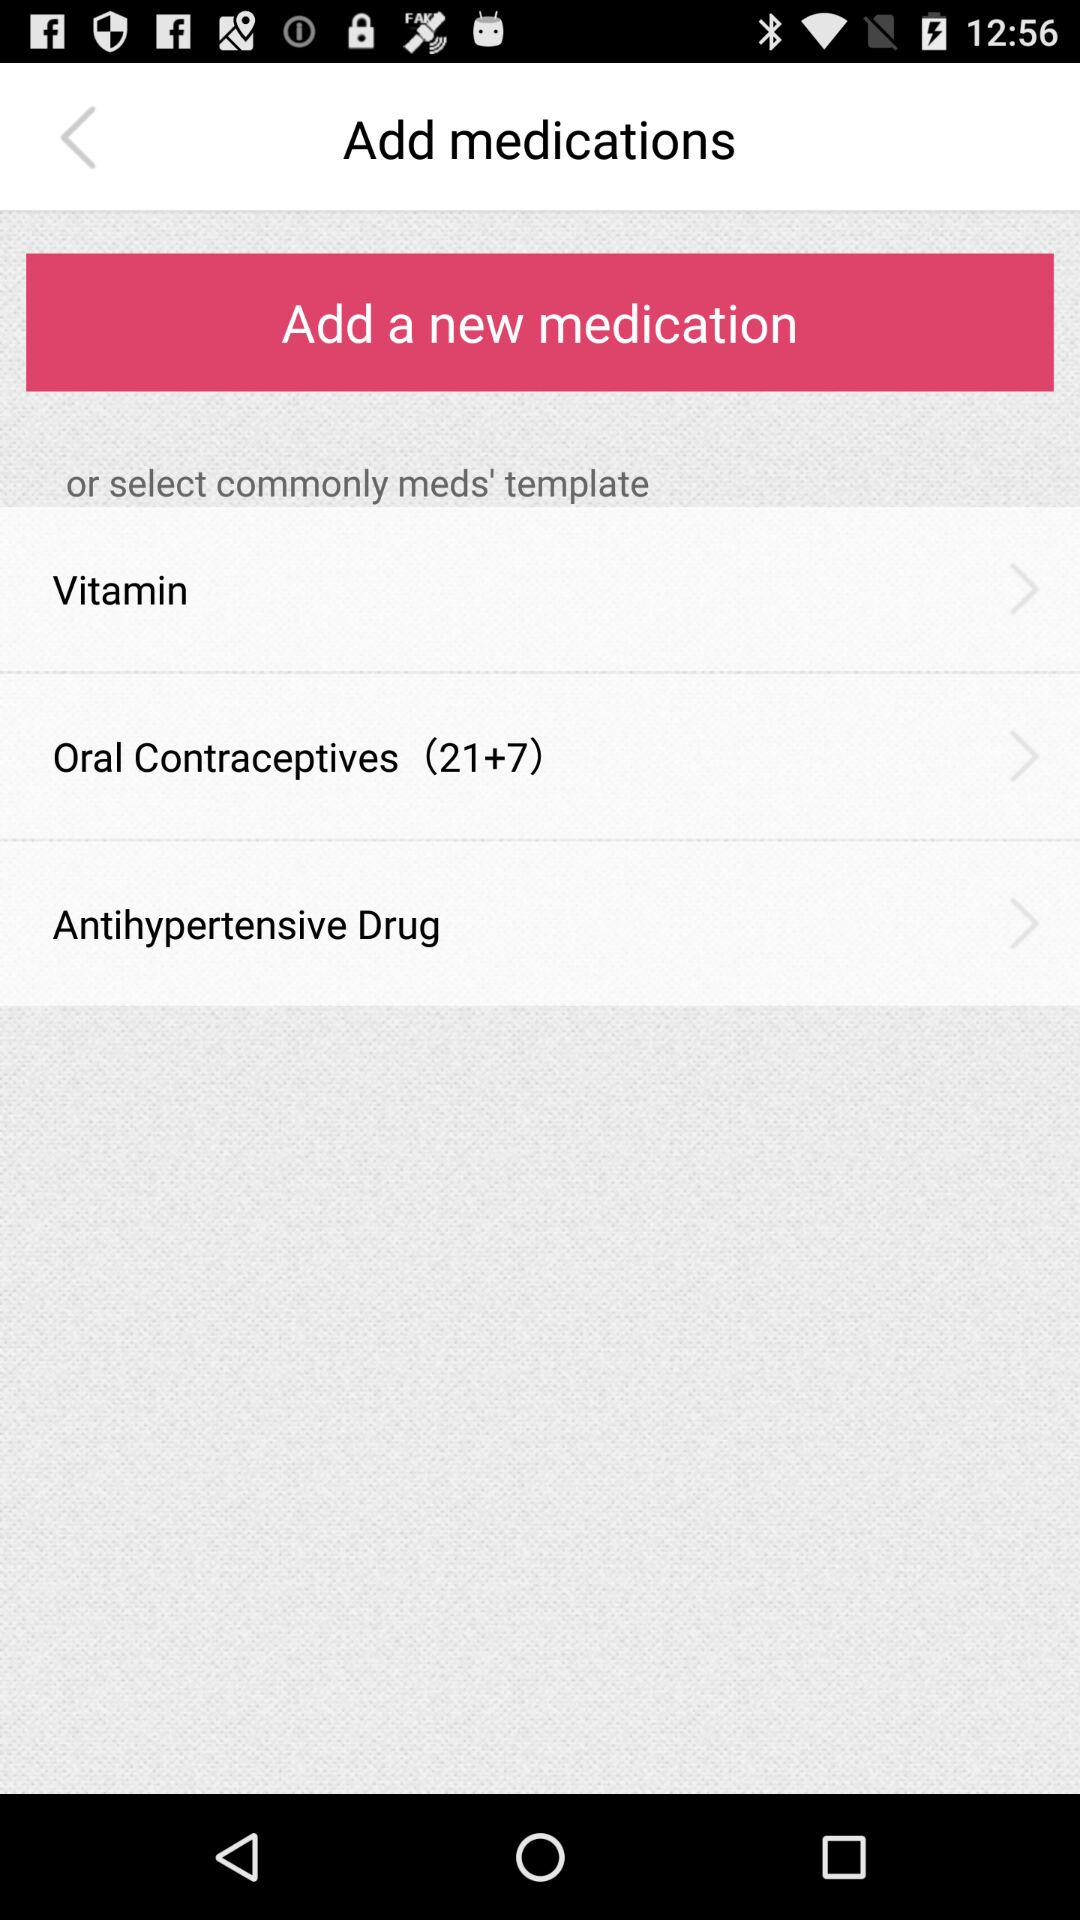What is the number for "Oral Contraceptives"? The numbers are 21 and 7. 